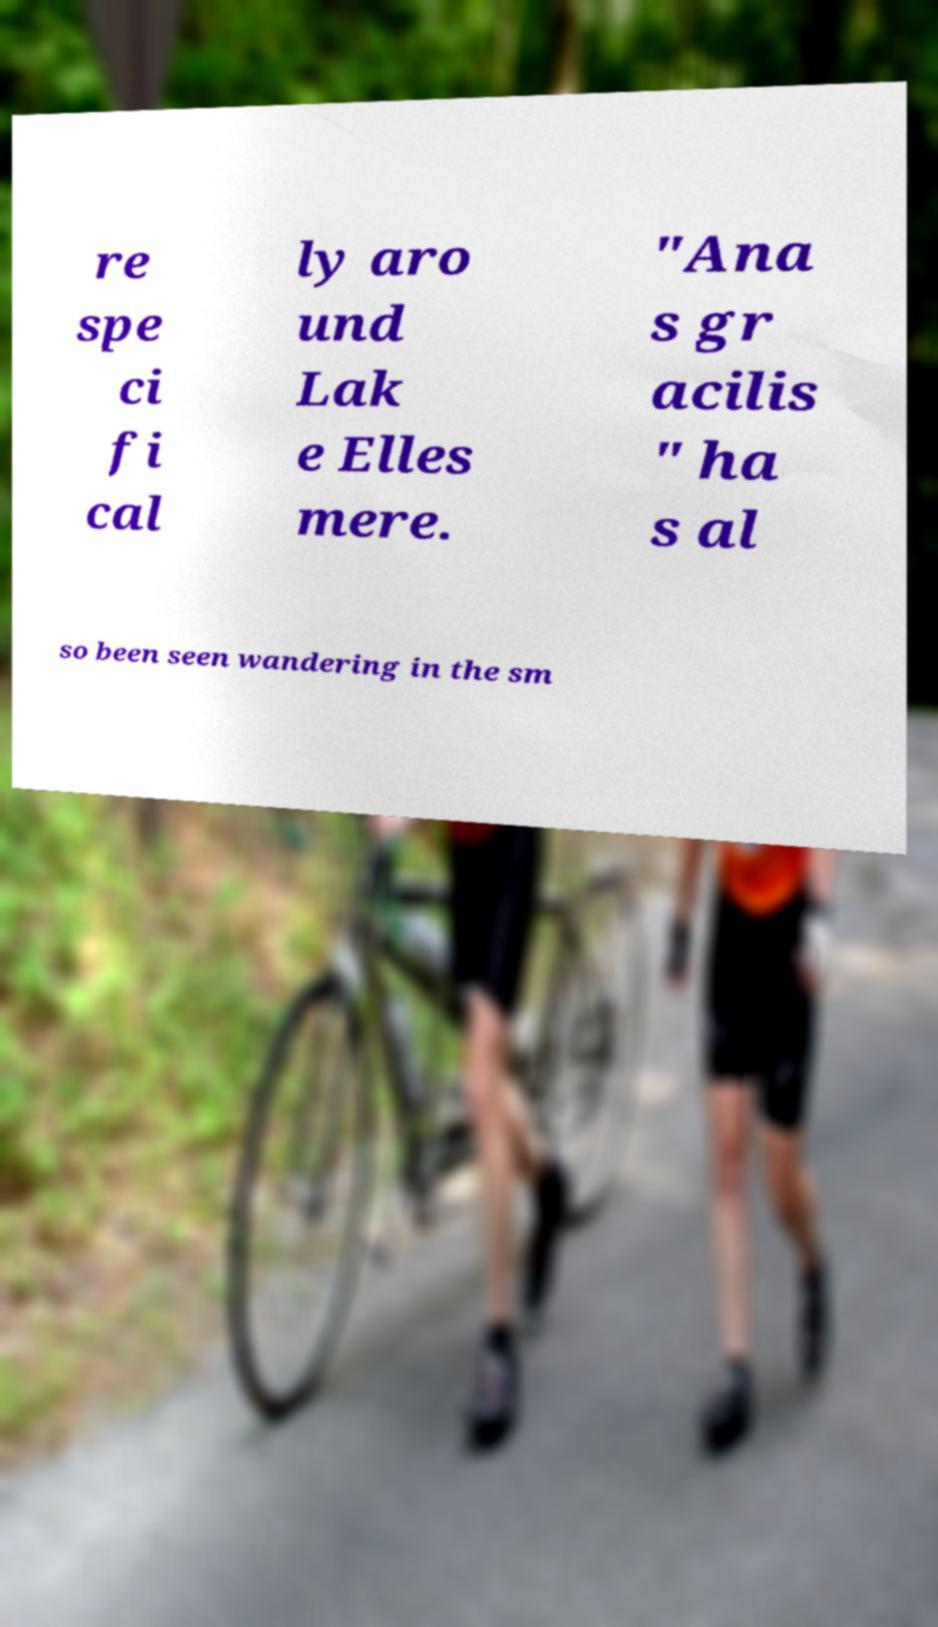I need the written content from this picture converted into text. Can you do that? re spe ci fi cal ly aro und Lak e Elles mere. "Ana s gr acilis " ha s al so been seen wandering in the sm 